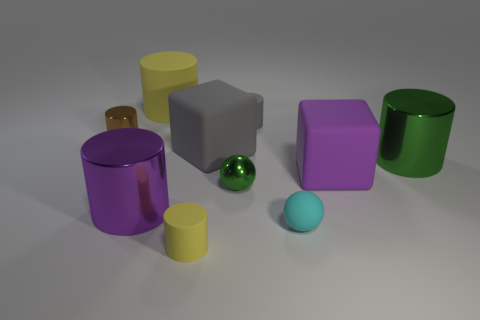Beside color and reflectivity, can you describe any other attribute differences among the objects in the image? Absolutely. The objects in the image vary not only in color and reflectivity but also in their shapes and sizes. For example, we see cubes and cylinders of various dimensions, as well as a spherical object that has a shiny, reflective green surface. Furthermore, the objects have different surface textures; some appear smooth, while others look matte. 